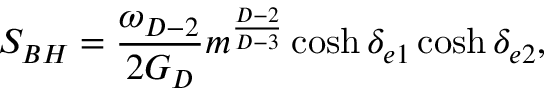<formula> <loc_0><loc_0><loc_500><loc_500>S _ { B H } = { \frac { \omega _ { D - 2 } } { 2 G _ { D } } } m ^ { \frac { D - 2 } { D - 3 } } \cosh \delta _ { e 1 } \cosh \delta _ { e 2 } ,</formula> 